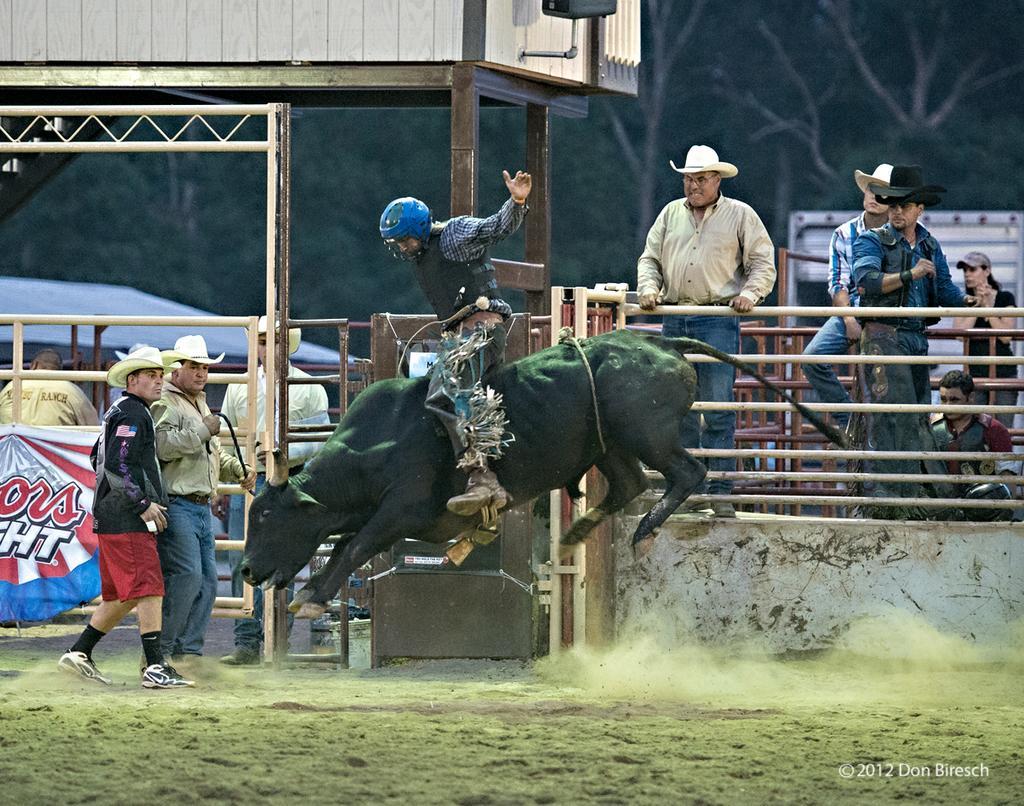Please provide a concise description of this image. In the foreground I can see a person is sitting on a bull and grass. In the background I can see a group of people are standing, fence, shed and trees. This image is taken may be on the ground. 